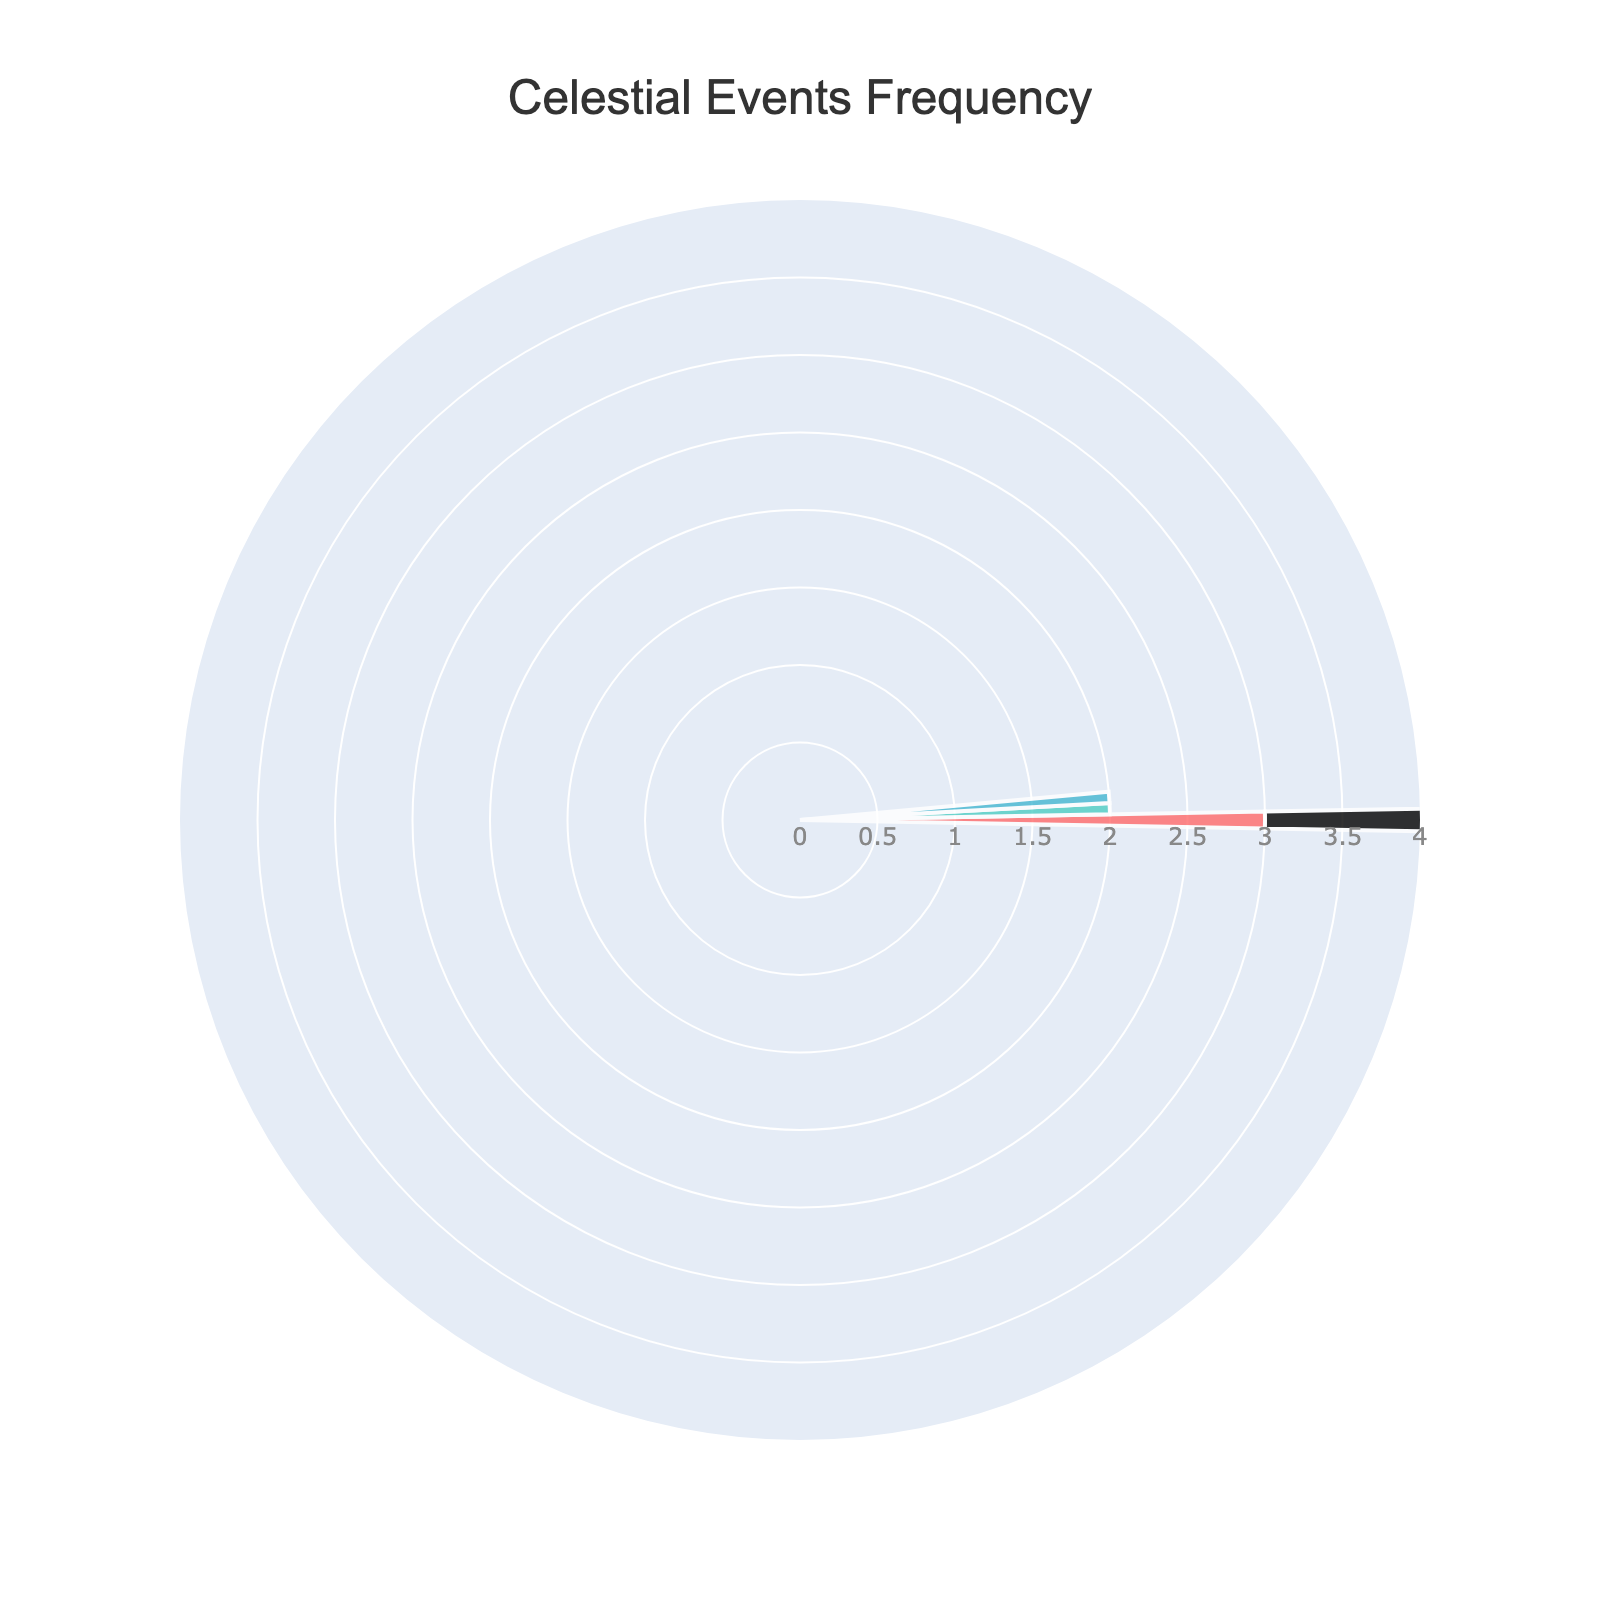What is the title of the chart? The title is usually placed at the top of the figure and is often in a larger font size. In this case, it reads "Celestial Events Frequency".
Answer: Celestial Events Frequency How many types of celestial events are represented in the chart? By looking at the number of colored segments, we can count three distinct segments in the chart.
Answer: 3 What is the frequency of Lunar Eclipses? By observing the lengths of the radial bars, the one labeled as "Lunar Eclipse" extends up to the third concentric circle, indicating its frequency.
Answer: 3 Which celestial event has the highest frequency? The event with the longest radial bar on the chart represents the highest frequency, which in this chart is "Lunar Eclipse" extending up to the third ring.
Answer: Lunar Eclipse What are the colors used to represent different celestial events? We can identify the segments/colors in the chart: one segment is red, another is teal, and another is light blue. These colors differentiate the events.
Answer: Red, Teal, Light Blue What is the combined frequency of Solar Eclipses and Conjunctions (Jupiter and Saturn)? Adding the frequencies of these two events: Solar Eclipses (2) and Conjunctions (2) results in a total of 4.
Answer: 4 How does the frequency of Solar Eclipses compare to Planetary Transits (Mercury)? By observing the lengths of the radial bars, Solar Eclipses have a length reaching the second ring while Planetary Transits extend to the first ring, meaning Solar Eclipses have a higher frequency.
Answer: Solar Eclipses have a higher frequency Which celestial event appears the least frequently? The event with the shortest radial bar signifies the fewest occurrences, which in this case is the "Planetary Transit (Mercury)" extending only to the first ring.
Answer: Planetary Transit (Mercury) How many more Lunar Eclipses are there than Solar Eclipses? Subtracting the frequency of Solar Eclipses (2) from that of Lunar Eclipses (3) gives the difference.
Answer: 1 Is the frequency of Conjunctions (Jupiter and Saturn) equal to any other event? We look for other radial bars that extend to the same ring as the Conjunctions. Here, Conjunctions (2) match the length of Solar Eclipses (2).
Answer: Yes 